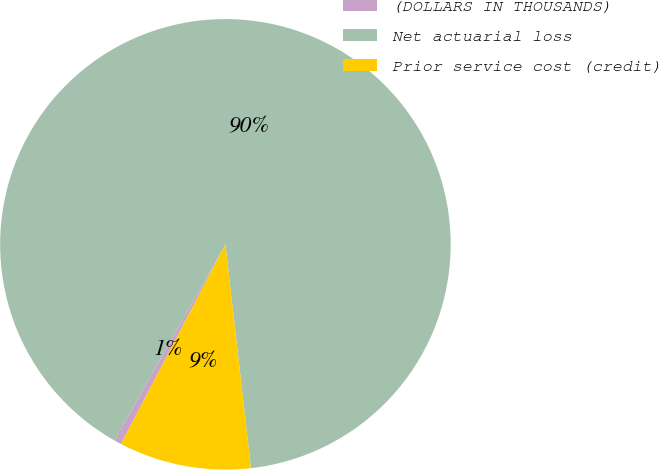Convert chart to OTSL. <chart><loc_0><loc_0><loc_500><loc_500><pie_chart><fcel>(DOLLARS IN THOUSANDS)<fcel>Net actuarial loss<fcel>Prior service cost (credit)<nl><fcel>0.53%<fcel>89.99%<fcel>9.48%<nl></chart> 